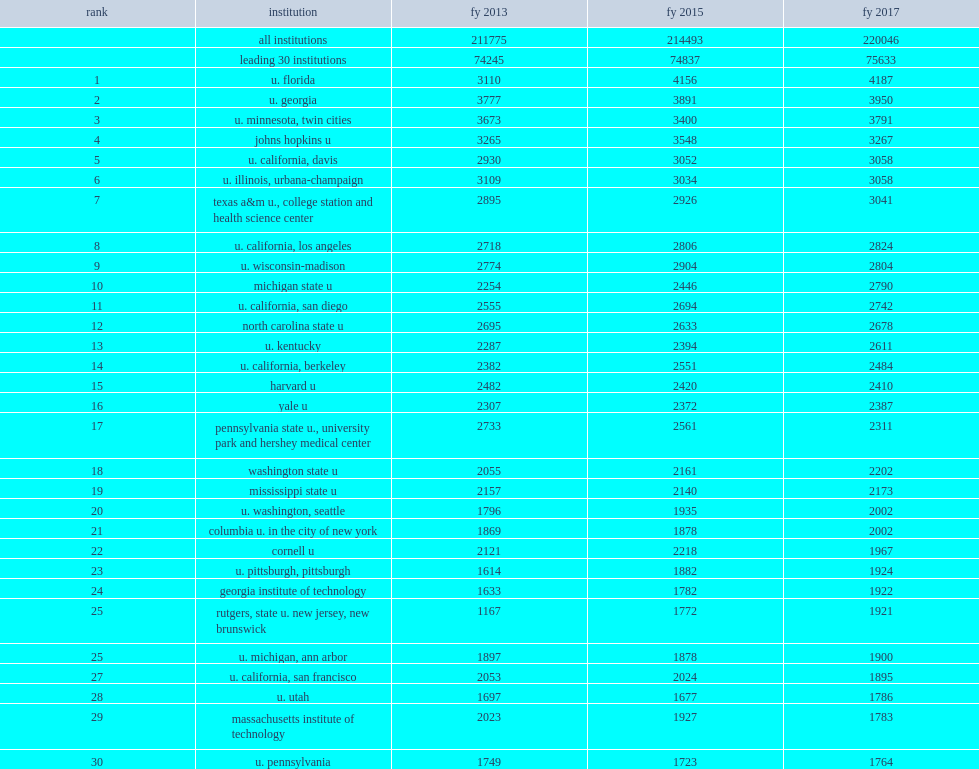Of the 575 institutions surveyed, how many percent did the top 30 institutions ranked by total s&e nasf account of all research space in fy 2017? 0.343714. 